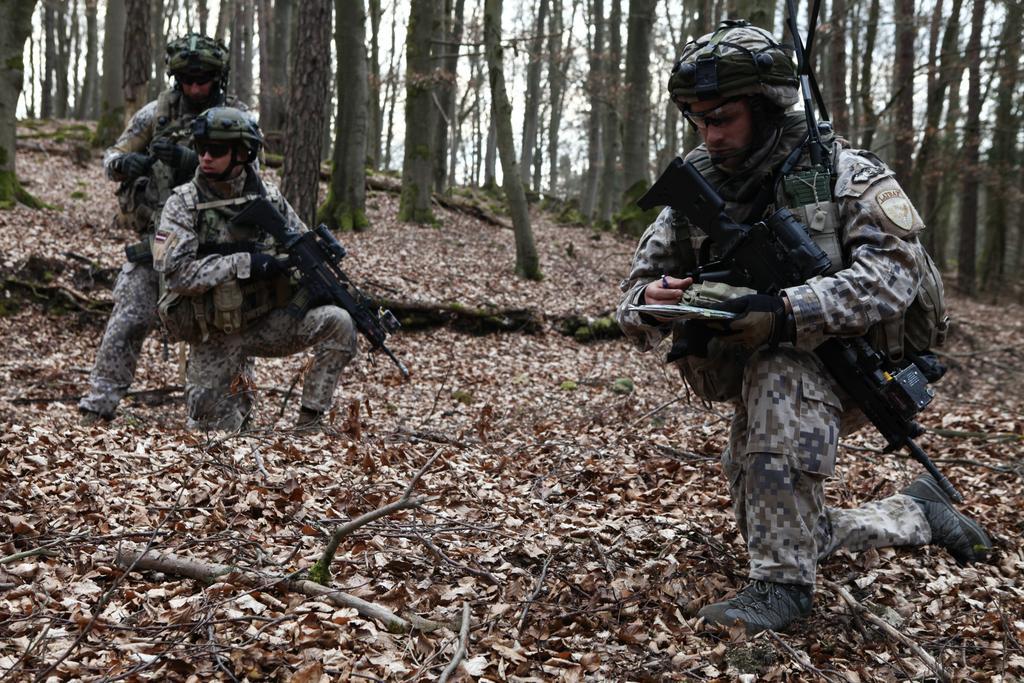How would you summarize this image in a sentence or two? In this image, we can see a few people holding guns. We can also see the ground covered with leaves and some wood. There are some trees. We can also see the sky. 